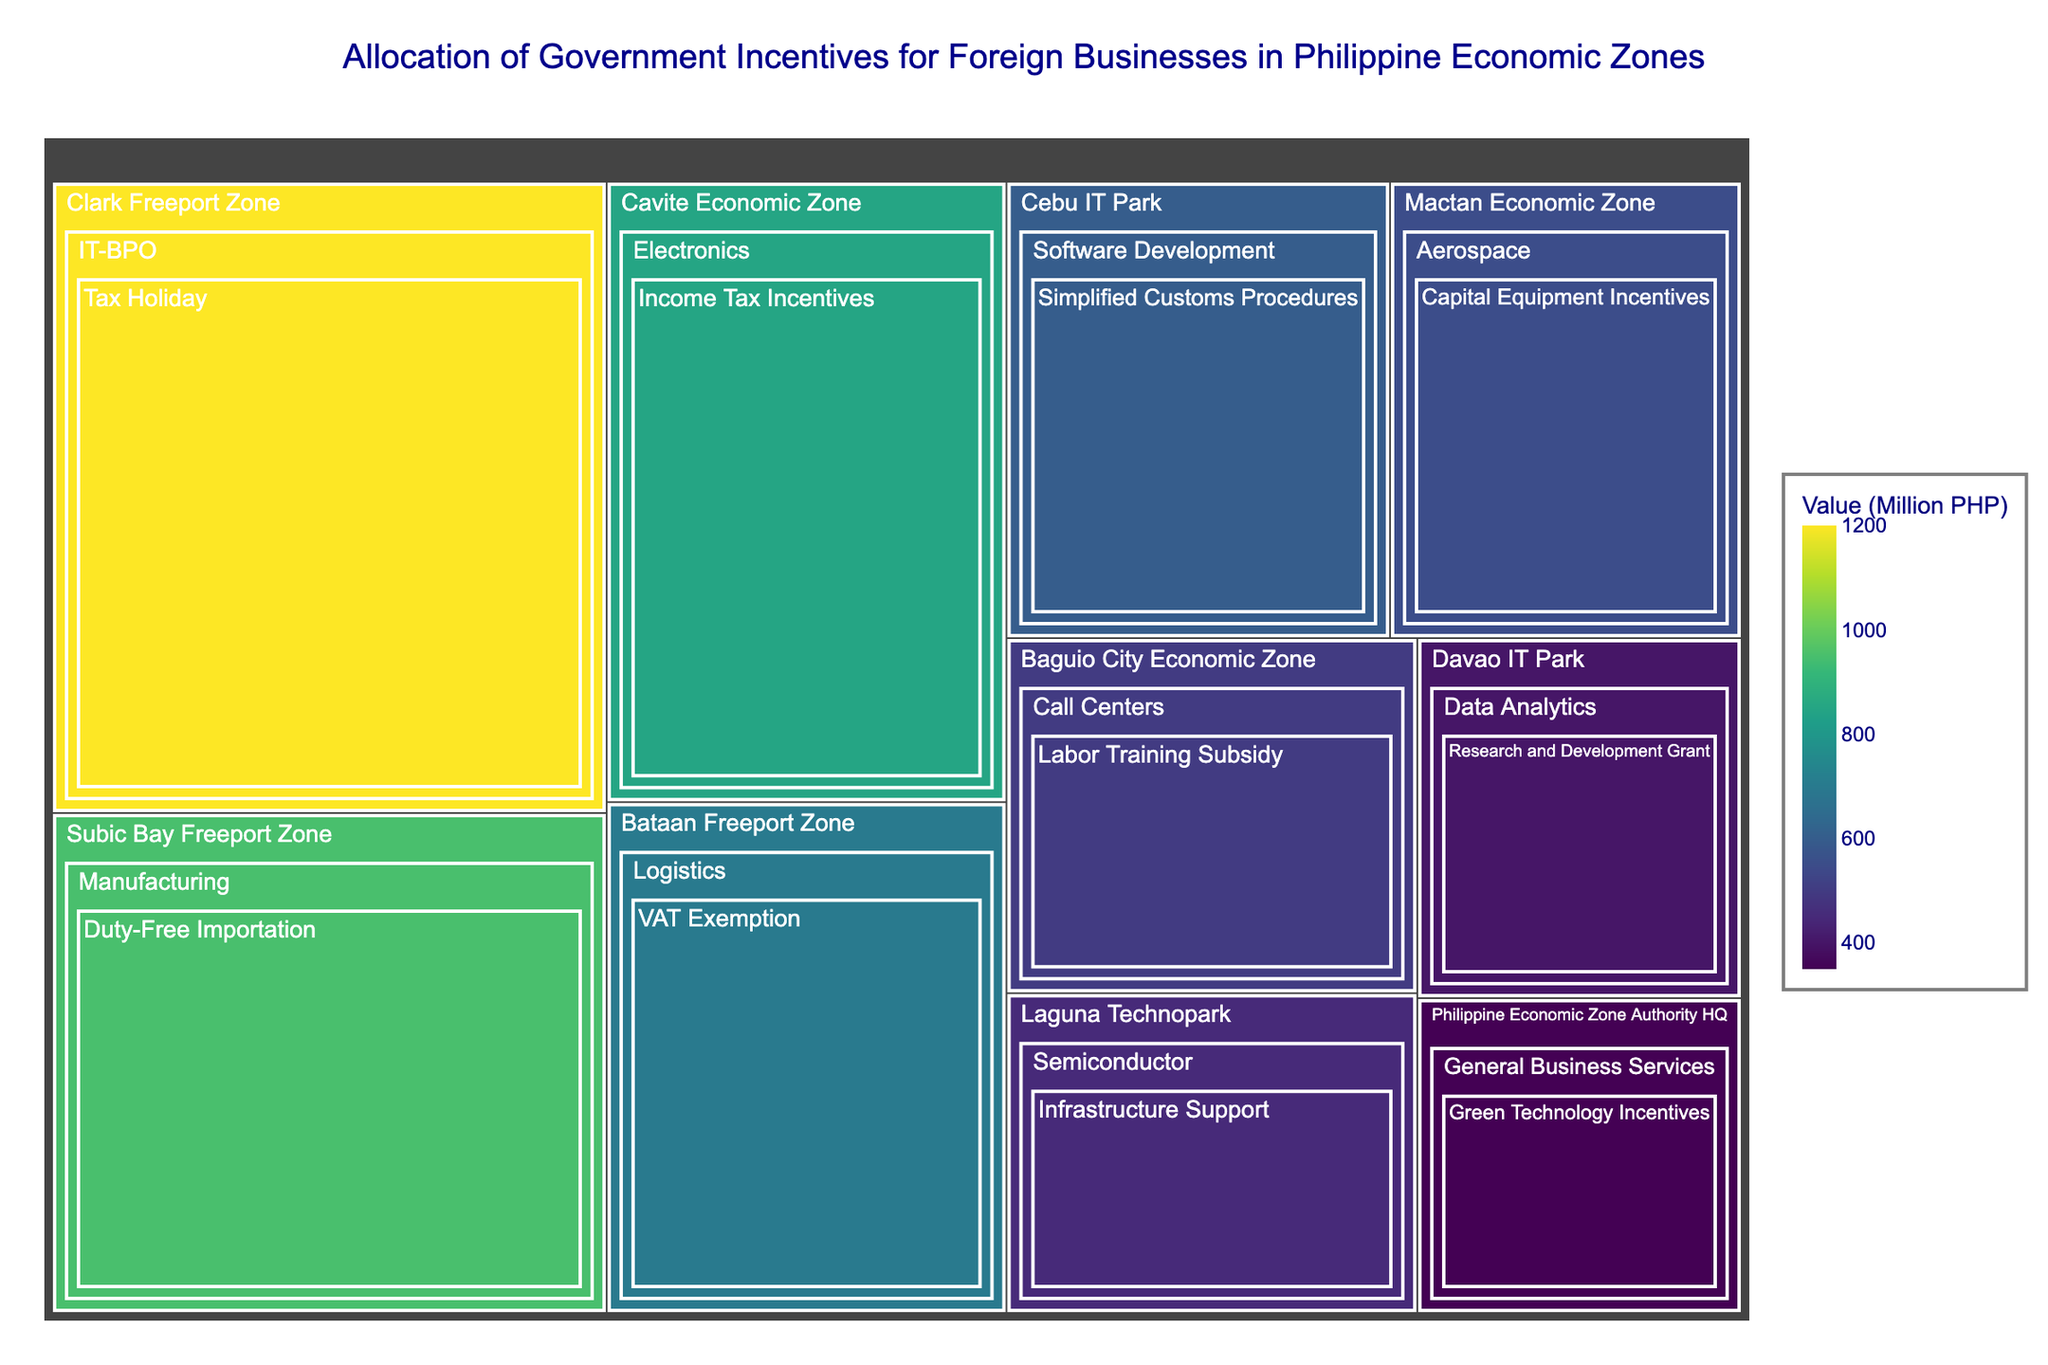What is the title of the treemap? The title is typically found at the top of the figure. The visual information specifies it as 'Allocation of Government Incentives for Foreign Businesses in Philippine Economic Zones'.
Answer: Allocation of Government Incentives for Foreign Businesses in Philippine Economic Zones Which economic zone received the highest value of incentives? To determine which economic zone received the highest amount of incentives, look for the largest tile in the treemap. The Clark Freeport Zone stands out with the largest tile having a value of 1200 Million PHP.
Answer: Clark Freeport Zone How much incentive was allocated to Davao IT Park? Locate Davao IT Park within the treemap and find the value associated with it. The tile indicates 400 Million PHP.
Answer: 400 Million PHP Which sector in the Subic Bay Freeport Zone received the government incentive? Look at the Subic Bay Freeport Zone and notice the sector specified within that area. The sector listed is Manufacturing.
Answer: Manufacturing What type of incentive did the software development sector in Cebu IT Park receive? Find Cebu IT Park and then look for the detailed breakdown of the sector, which is Software Development. The specific incentive type indicated is Simplified Customs Procedures.
Answer: Simplified Customs Procedures What's the difference in incentive value between the Bataan Freeport Zone and the Philippine Economic Zone Authority HQ? The Bataan Freeport Zone received 700 Million PHP while the Philippine Economic Zone Authority HQ received 350 Million PHP. The difference is calculated as 700 - 350 = 350.
Answer: 350 Million PHP Which economic zone has the lowest amount of incentives allocated? Identify the smallest tile in the treemap representing the value of incentives. The smallest tile, corresponding to 350 Million PHP, belongs to the Philippine Economic Zone Authority HQ.
Answer: Philippine Economic Zone Authority HQ In how many different economic zones are IT-related sectors receiving incentives? Look through the treemap and count the number of economic zones with IT-related sectors such as IT-BPO, Software Development, Call Centers, and Data Analytics. There are zones: Clark Freeport Zone, Cebu IT Park, Baguio City Economic Zone, and Davao IT Park.
Answer: 4 If you combine the incentives for Clark Freeport Zone and Subic Bay Freeport Zone, what is the total value? The incentive for Clark Freeport Zone is 1200 Million PHP and for Subic Bay Freeport Zone is 950 Million PHP. Adding these together, 1200 + 950 = 2150.
Answer: 2150 Million PHP Which sector received incentives for infrastructure support, and in which economic zone is it located? Identify the sector receiving infrastructure support by looking through the incentive types. It is the Semiconductor sector located in the Laguna Technopark.
Answer: Semiconductor in Laguna Technopark 